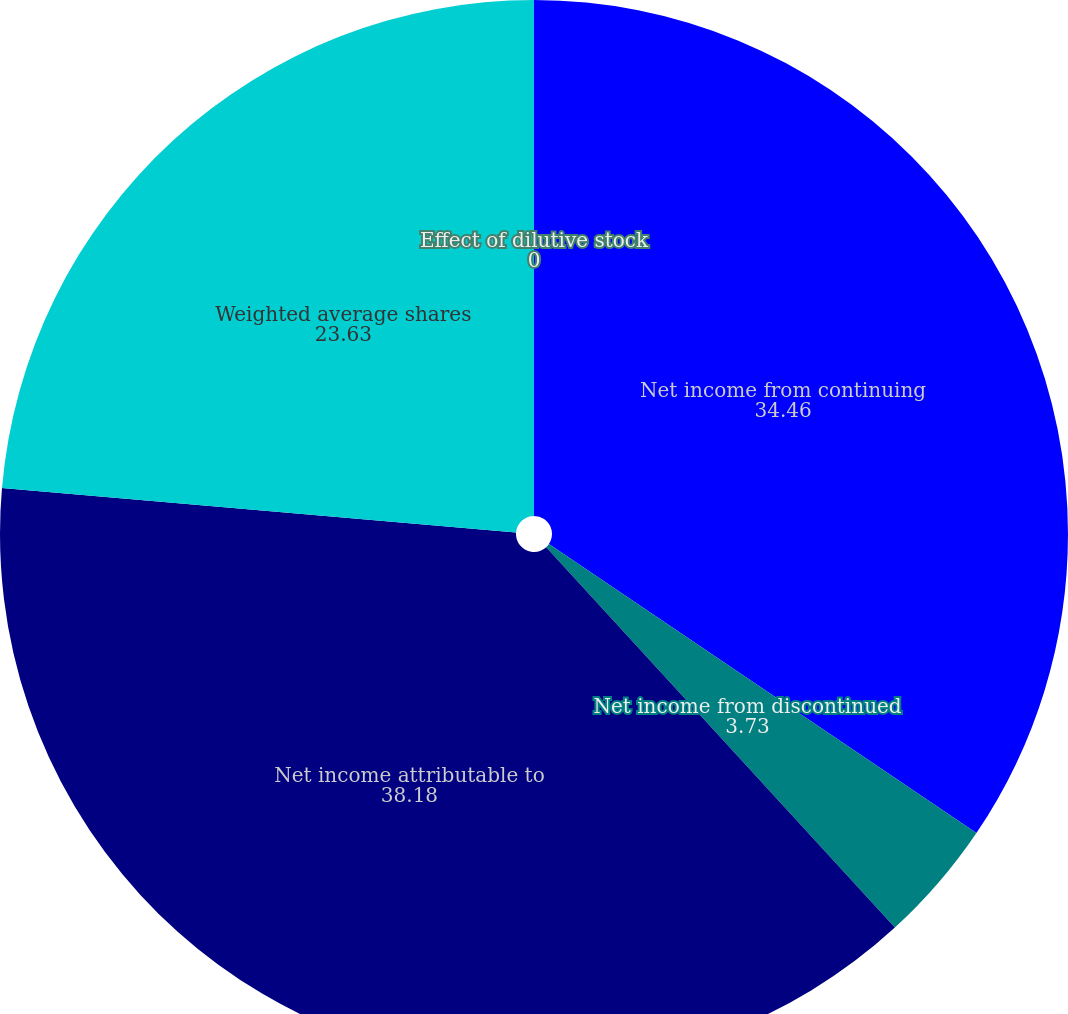Convert chart to OTSL. <chart><loc_0><loc_0><loc_500><loc_500><pie_chart><fcel>Net income from continuing<fcel>Net income from discontinued<fcel>Net income attributable to<fcel>Weighted average shares<fcel>Effect of dilutive stock<nl><fcel>34.46%<fcel>3.73%<fcel>38.18%<fcel>23.63%<fcel>0.0%<nl></chart> 